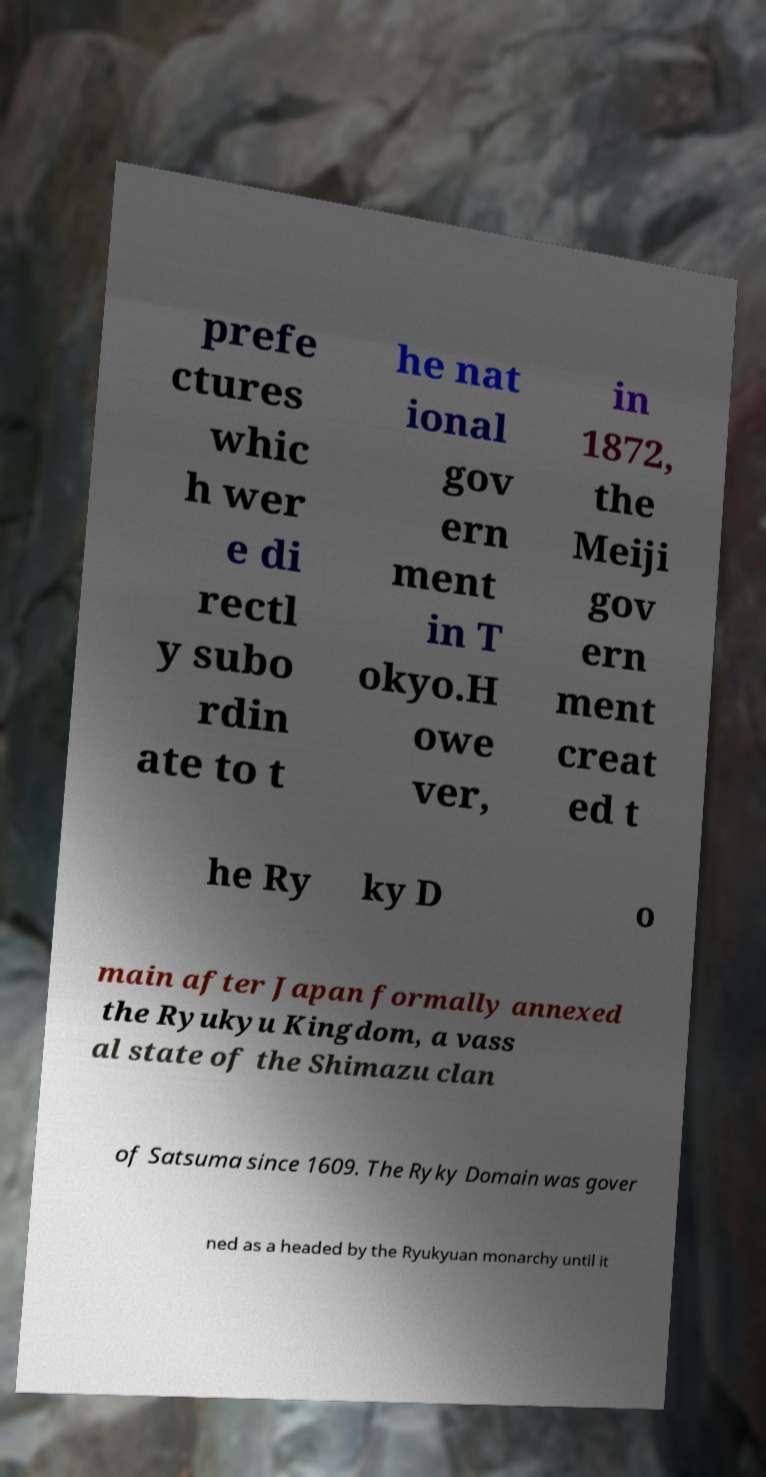What messages or text are displayed in this image? I need them in a readable, typed format. prefe ctures whic h wer e di rectl y subo rdin ate to t he nat ional gov ern ment in T okyo.H owe ver, in 1872, the Meiji gov ern ment creat ed t he Ry ky D o main after Japan formally annexed the Ryukyu Kingdom, a vass al state of the Shimazu clan of Satsuma since 1609. The Ryky Domain was gover ned as a headed by the Ryukyuan monarchy until it 